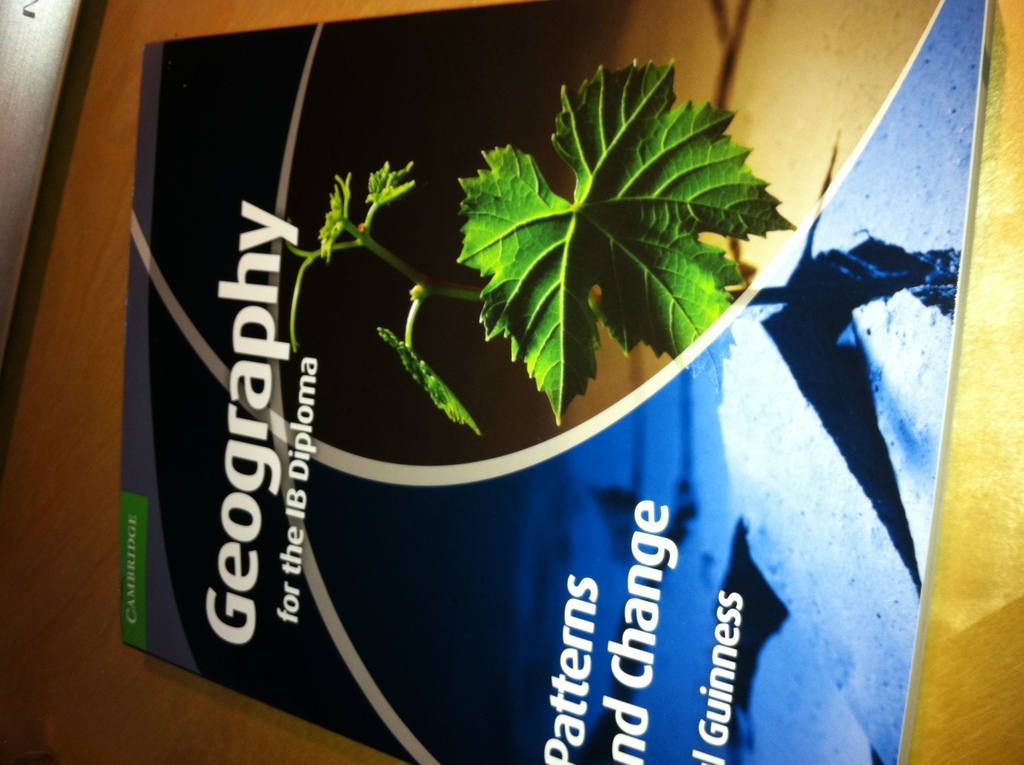How does the imagery of shadows and light play into the theme of the book? The interplay of shadows and light on the book's cover could symbolize the dynamic and ever-changing nature of geographical patterns and phenomena, reflecting the complexity and depth of studying changes in physical geography. 